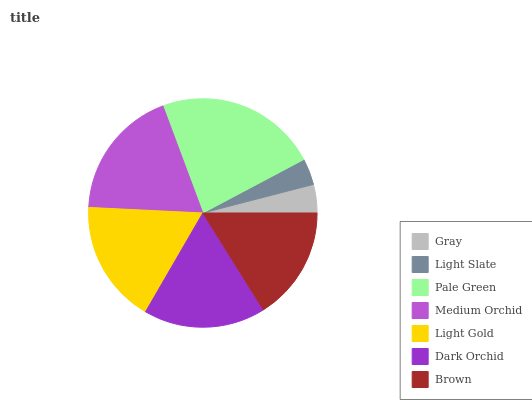Is Light Slate the minimum?
Answer yes or no. Yes. Is Pale Green the maximum?
Answer yes or no. Yes. Is Pale Green the minimum?
Answer yes or no. No. Is Light Slate the maximum?
Answer yes or no. No. Is Pale Green greater than Light Slate?
Answer yes or no. Yes. Is Light Slate less than Pale Green?
Answer yes or no. Yes. Is Light Slate greater than Pale Green?
Answer yes or no. No. Is Pale Green less than Light Slate?
Answer yes or no. No. Is Dark Orchid the high median?
Answer yes or no. Yes. Is Dark Orchid the low median?
Answer yes or no. Yes. Is Medium Orchid the high median?
Answer yes or no. No. Is Pale Green the low median?
Answer yes or no. No. 